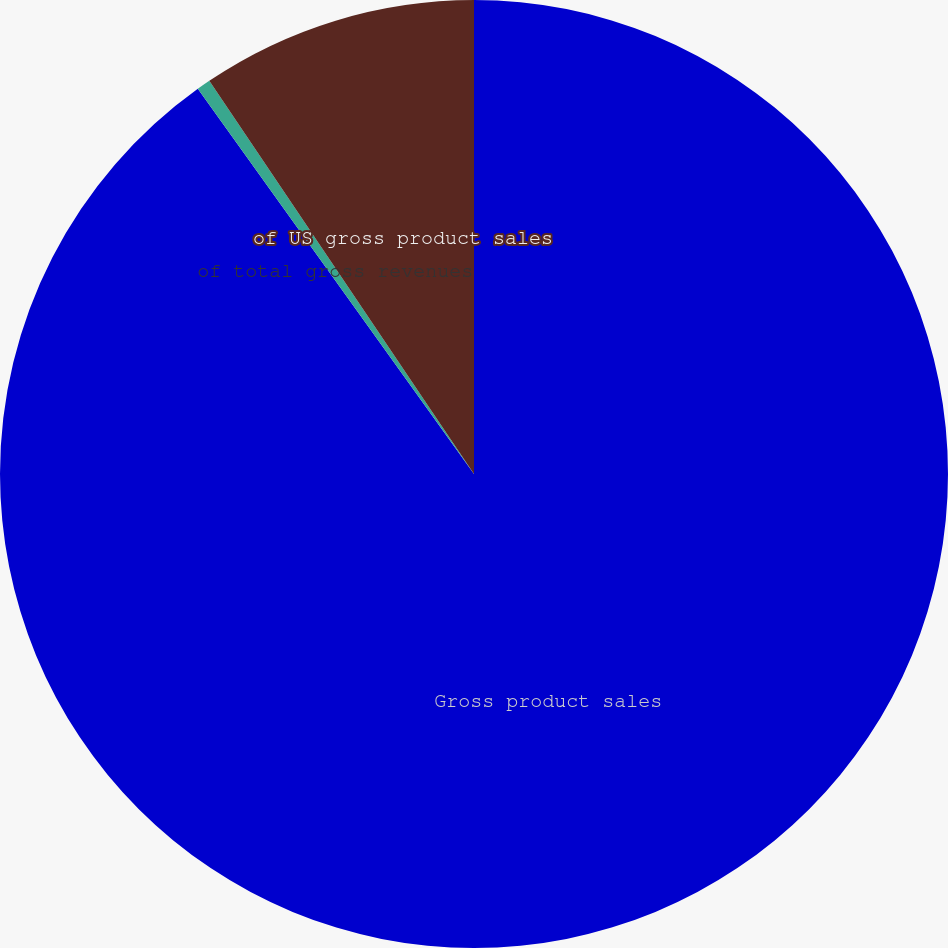Convert chart. <chart><loc_0><loc_0><loc_500><loc_500><pie_chart><fcel>Gross product sales<fcel>of total gross revenues<fcel>of US gross product sales<nl><fcel>90.1%<fcel>0.47%<fcel>9.43%<nl></chart> 